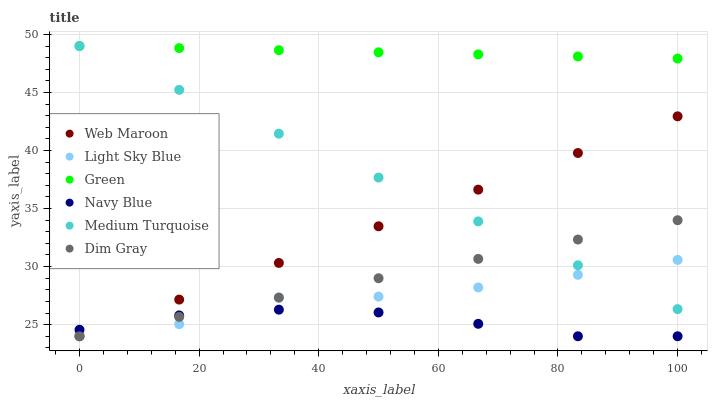Does Navy Blue have the minimum area under the curve?
Answer yes or no. Yes. Does Green have the maximum area under the curve?
Answer yes or no. Yes. Does Web Maroon have the minimum area under the curve?
Answer yes or no. No. Does Web Maroon have the maximum area under the curve?
Answer yes or no. No. Is Web Maroon the smoothest?
Answer yes or no. Yes. Is Light Sky Blue the roughest?
Answer yes or no. Yes. Is Navy Blue the smoothest?
Answer yes or no. No. Is Navy Blue the roughest?
Answer yes or no. No. Does Dim Gray have the lowest value?
Answer yes or no. Yes. Does Light Sky Blue have the lowest value?
Answer yes or no. No. Does Medium Turquoise have the highest value?
Answer yes or no. Yes. Does Web Maroon have the highest value?
Answer yes or no. No. Is Web Maroon less than Green?
Answer yes or no. Yes. Is Green greater than Web Maroon?
Answer yes or no. Yes. Does Medium Turquoise intersect Light Sky Blue?
Answer yes or no. Yes. Is Medium Turquoise less than Light Sky Blue?
Answer yes or no. No. Is Medium Turquoise greater than Light Sky Blue?
Answer yes or no. No. Does Web Maroon intersect Green?
Answer yes or no. No. 